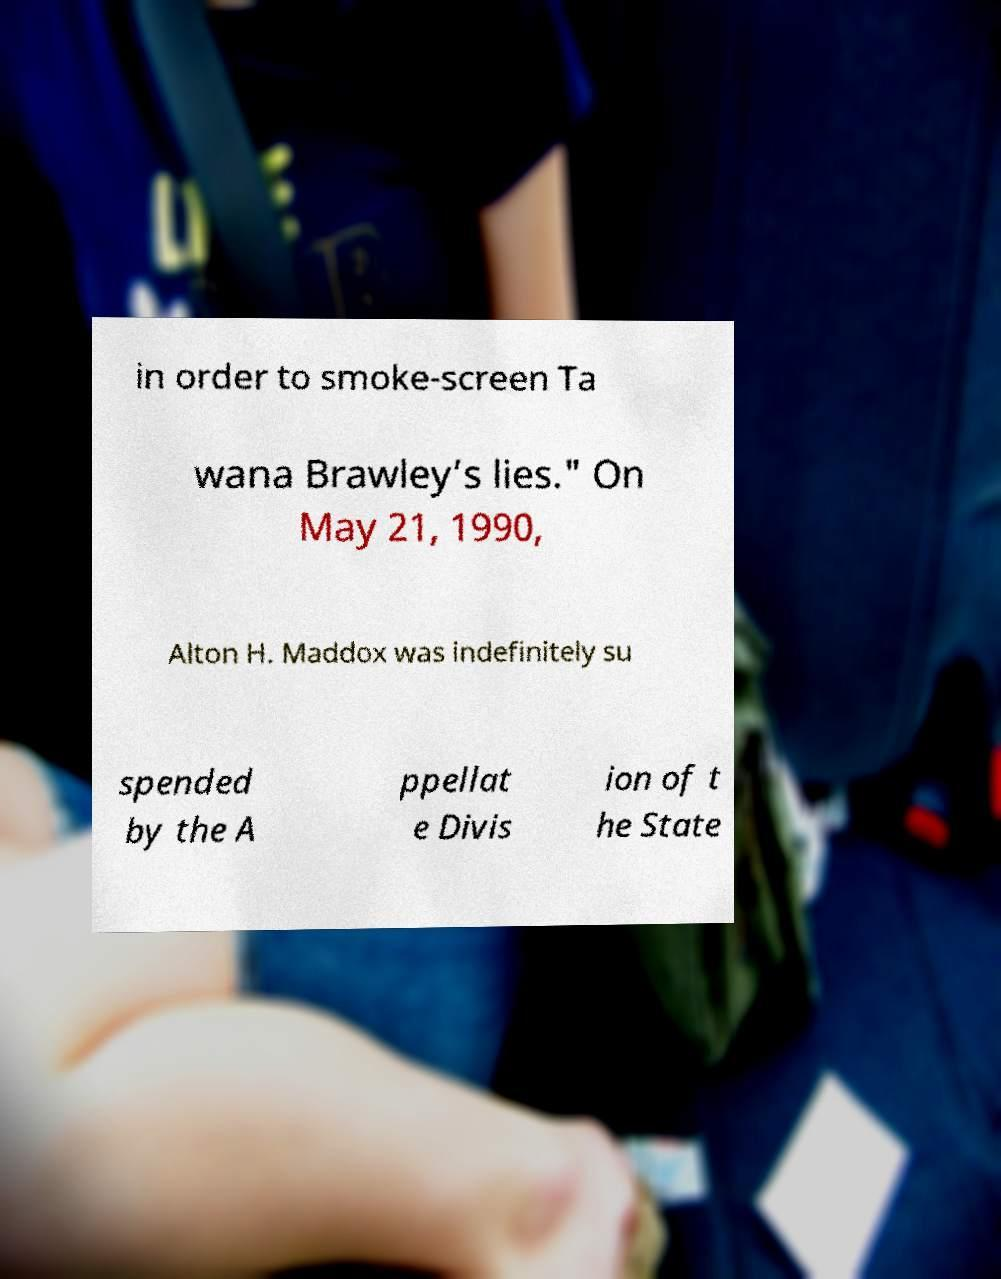There's text embedded in this image that I need extracted. Can you transcribe it verbatim? in order to smoke-screen Ta wana Brawley’s lies." On May 21, 1990, Alton H. Maddox was indefinitely su spended by the A ppellat e Divis ion of t he State 